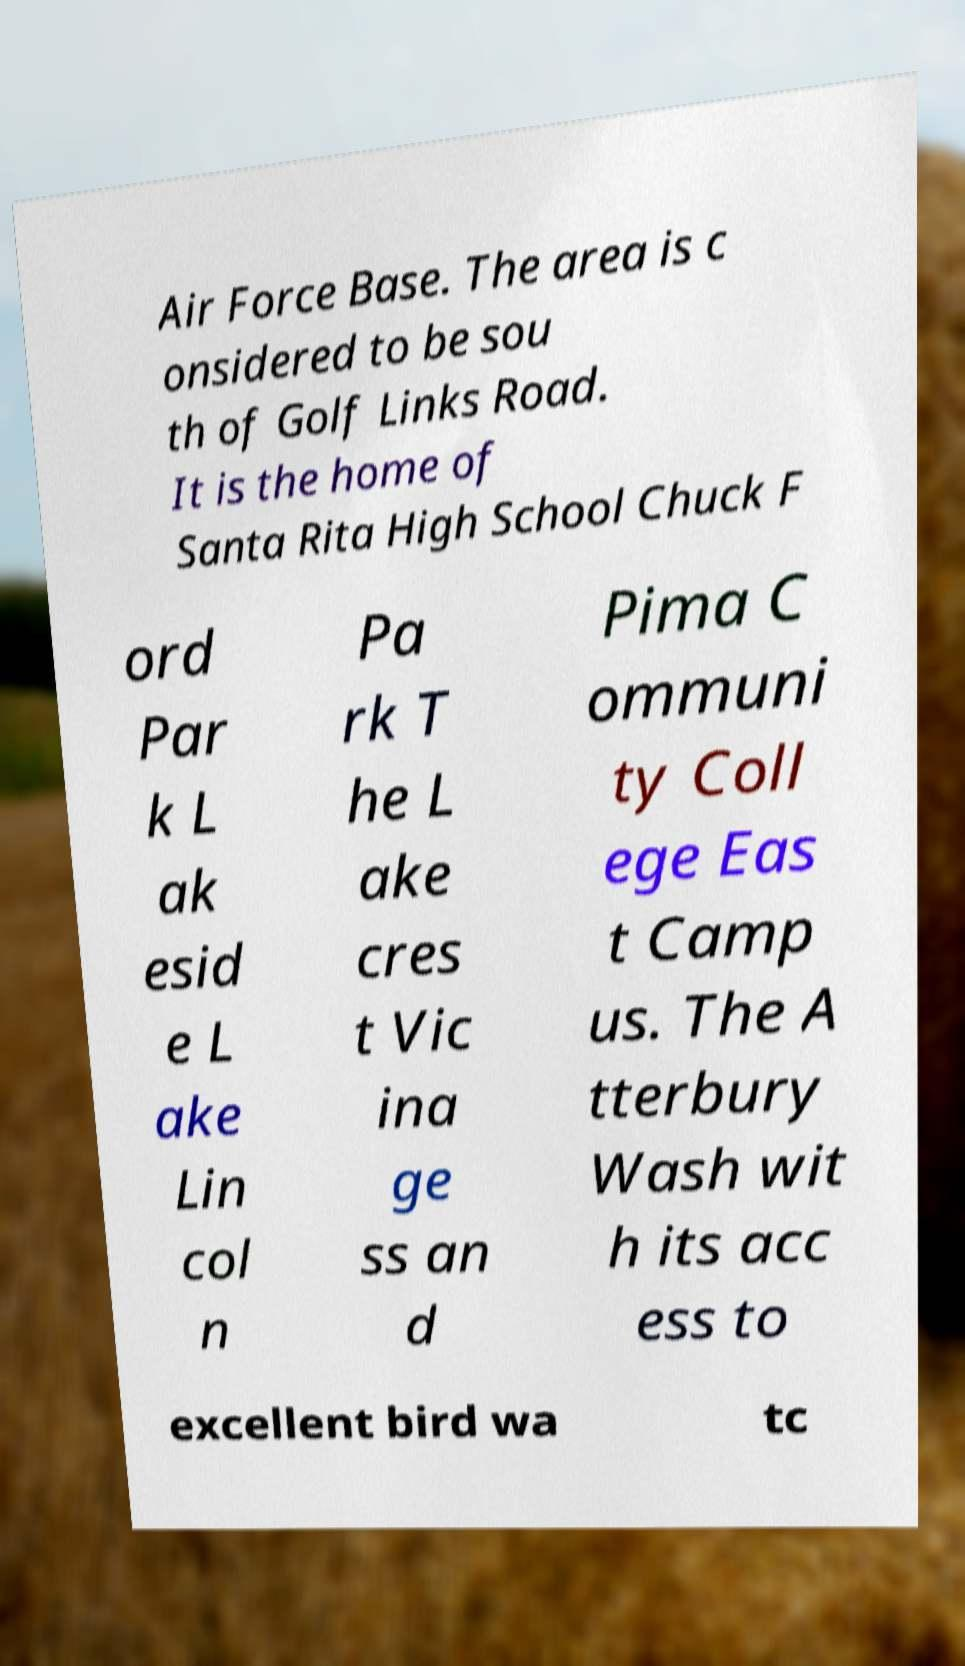Please identify and transcribe the text found in this image. Air Force Base. The area is c onsidered to be sou th of Golf Links Road. It is the home of Santa Rita High School Chuck F ord Par k L ak esid e L ake Lin col n Pa rk T he L ake cres t Vic ina ge ss an d Pima C ommuni ty Coll ege Eas t Camp us. The A tterbury Wash wit h its acc ess to excellent bird wa tc 